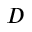Convert formula to latex. <formula><loc_0><loc_0><loc_500><loc_500>D</formula> 